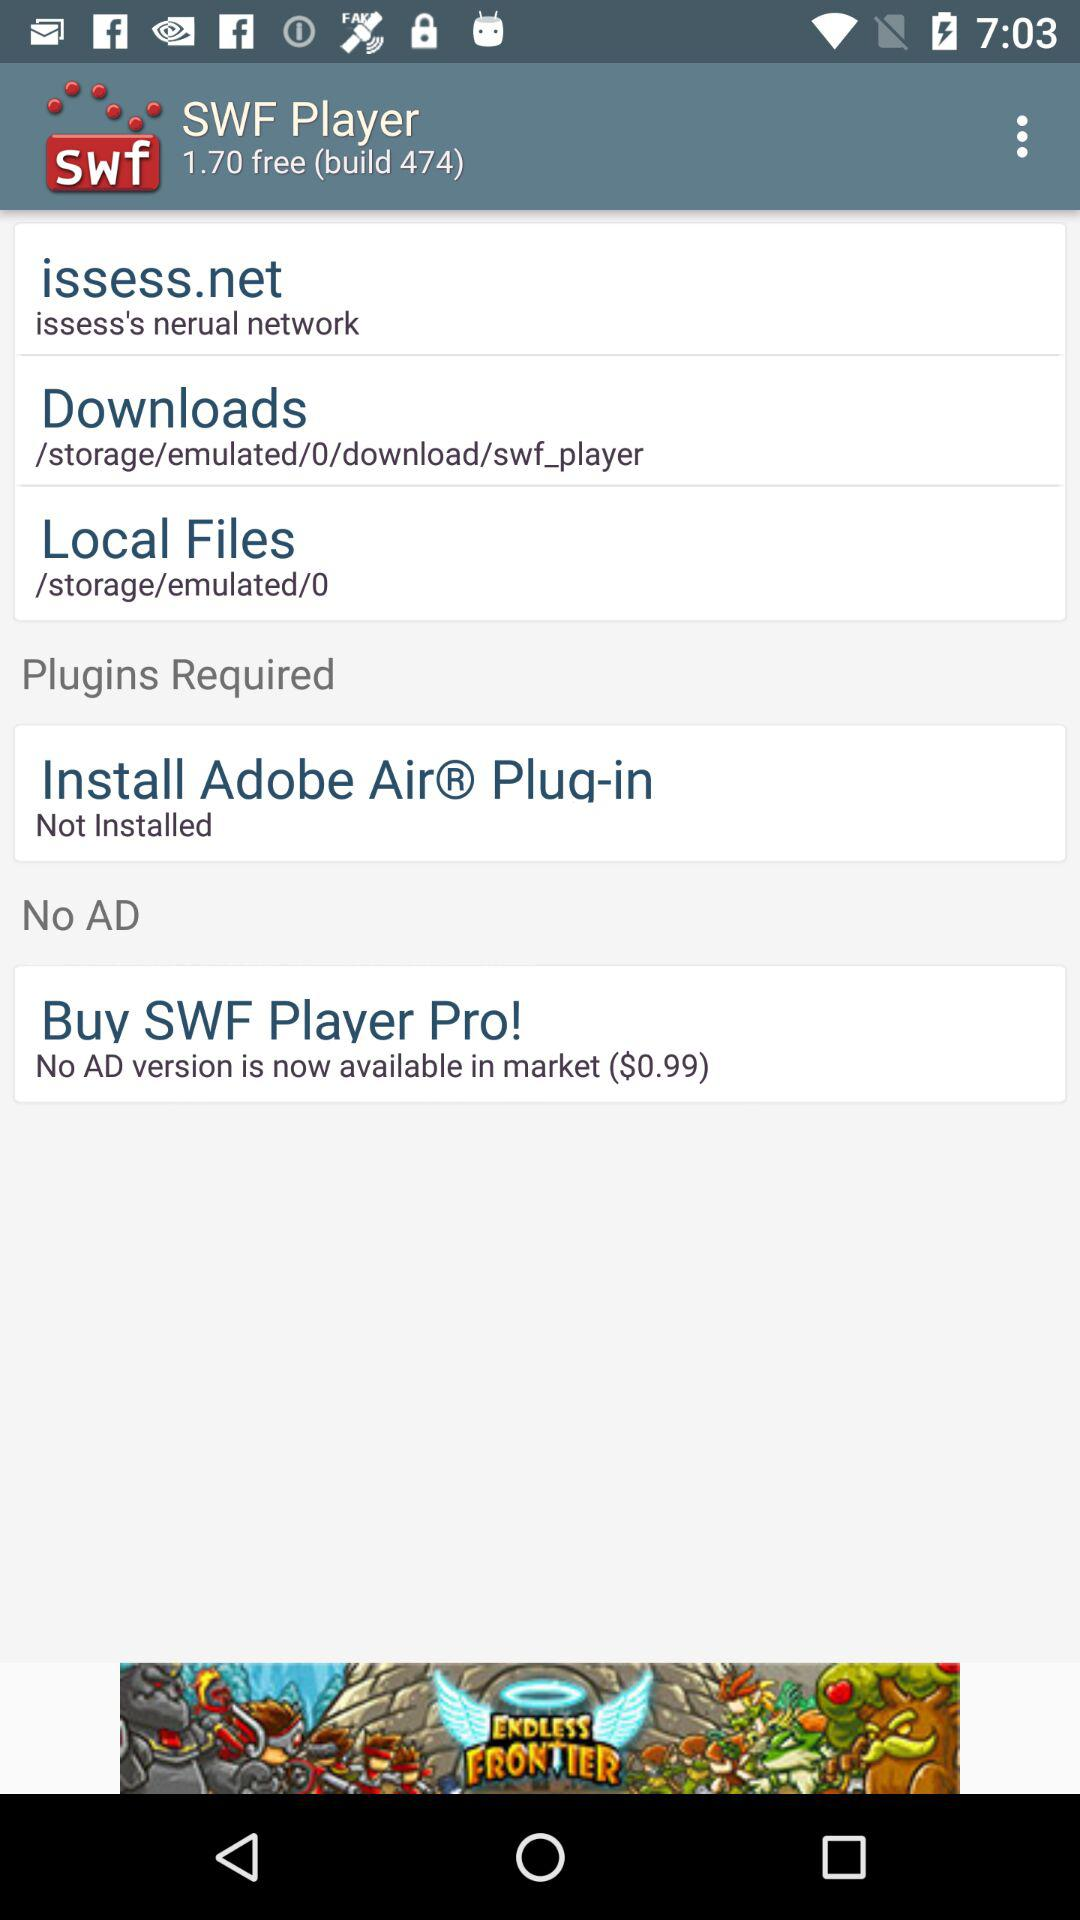What is the build number? The build number is 474. 